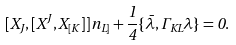<formula> <loc_0><loc_0><loc_500><loc_500>[ X _ { J } , [ X ^ { J } , X _ { [ K } ] ] n _ { L ] } + { \frac { 1 } { 4 } } \{ \bar { \lambda } , \Gamma _ { K L } \lambda \} = 0 .</formula> 